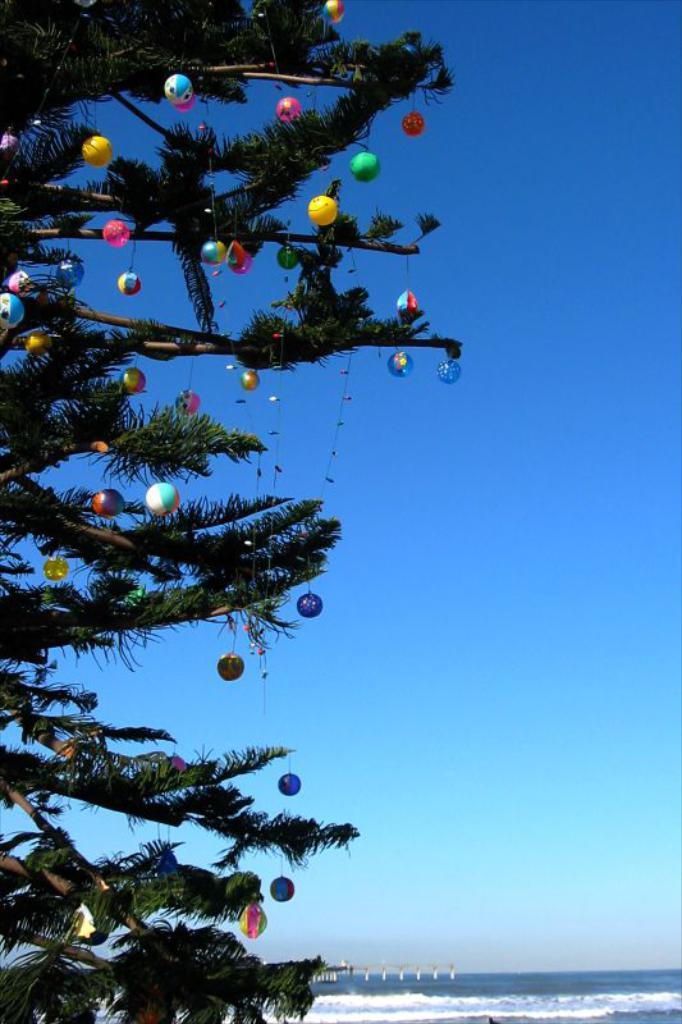What is located on the left side of the image? There is a Christmas tree on the left side of the image. What can be seen in the background of the image? The background of the image includes the sea. What else is visible in the background of the image? The sky is visible in the background of the image. How many pizzas are being delivered to the Christmas tree in the image? There are no pizzas present in the image, and therefore no delivery can be observed. What letters are being written by the beginner in the image? There is no person writing letters or any indication of a beginner in the image. 